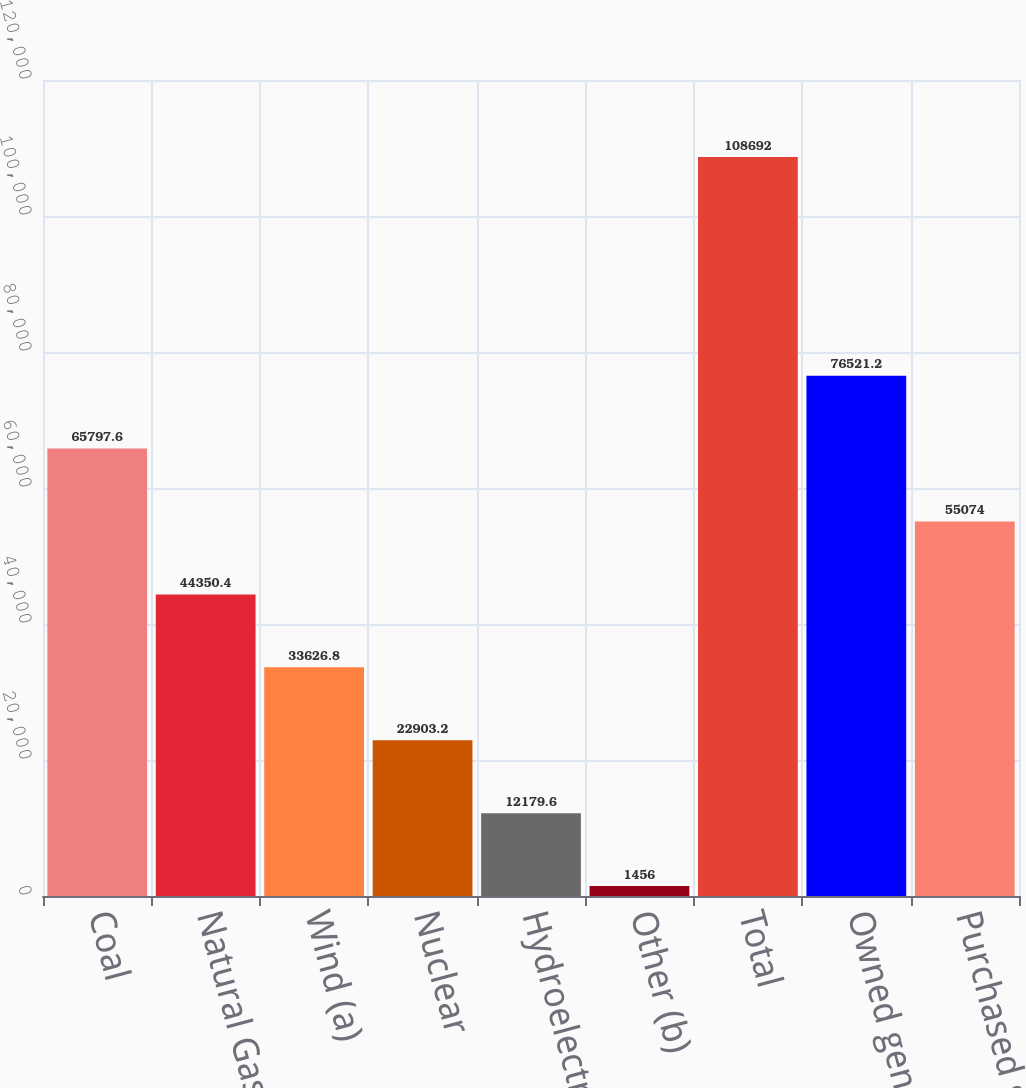Convert chart. <chart><loc_0><loc_0><loc_500><loc_500><bar_chart><fcel>Coal<fcel>Natural Gas<fcel>Wind (a)<fcel>Nuclear<fcel>Hydroelectric<fcel>Other (b)<fcel>Total<fcel>Owned generation<fcel>Purchased generation<nl><fcel>65797.6<fcel>44350.4<fcel>33626.8<fcel>22903.2<fcel>12179.6<fcel>1456<fcel>108692<fcel>76521.2<fcel>55074<nl></chart> 